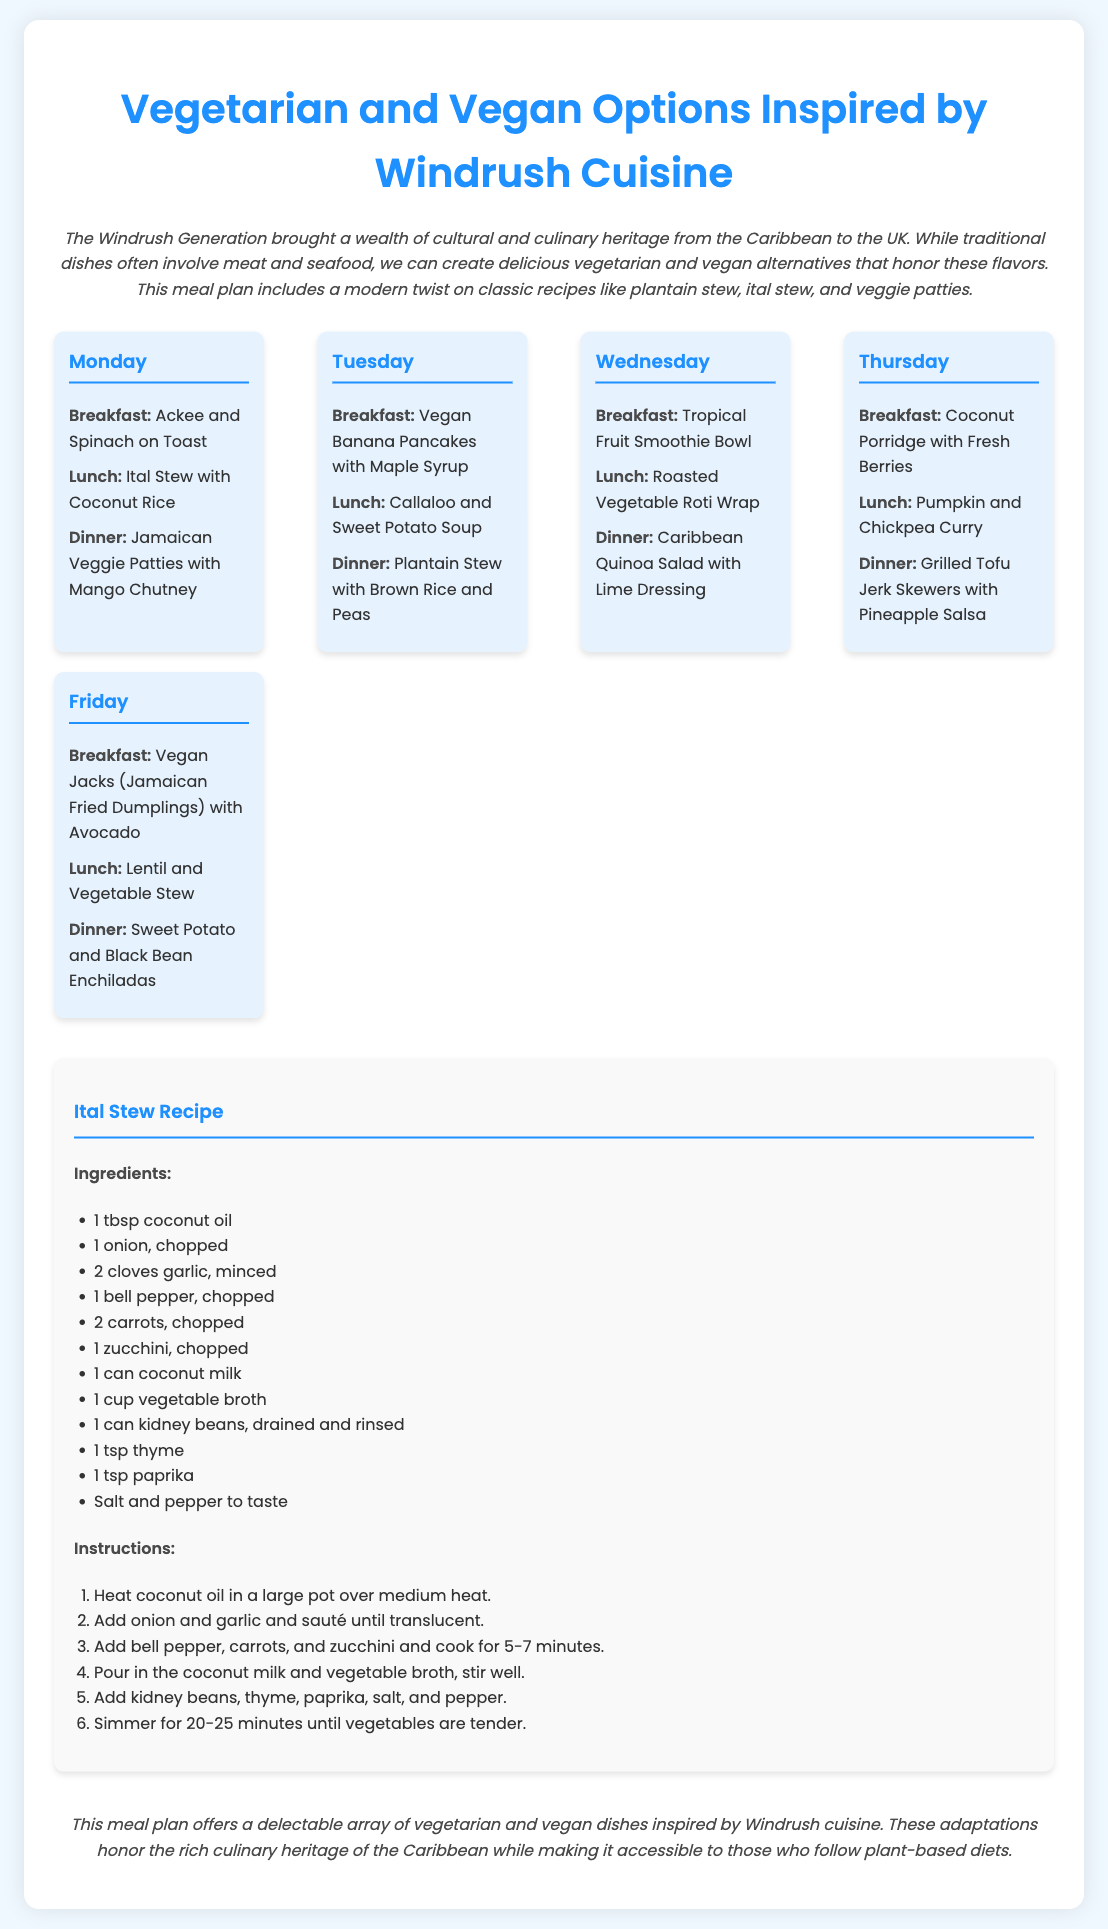What is the title of the document? The title of the document is specified in the <title> tag.
Answer: Vegetarian and Vegan Options Inspired by Windrush Cuisine How many days are included in the meal plan? The meal plan contains meals for five days, as indicated by the days listed.
Answer: Five What is the breakfast option for Tuesday? The breakfast option for Tuesday is listed in the corresponding section of the meal plan.
Answer: Vegan Banana Pancakes with Maple Syrup What main ingredient is used in the Ital Stew recipe? The main ingredients of the Ital Stew recipe are listed under the "Ingredients" section.
Answer: Coconut milk Which meal includes Jamaican Veggie Patties? The meal featuring Jamaican Veggie Patties is mentioned under the dinner section of one specific day.
Answer: Dinner on Monday How many ingredients are required for the Ital Stew recipe? The number of ingredients can be counted from the list provided in the recipe section.
Answer: Eleven What is the focus of the meal plan? The focus of the meal plan is described in the introductory paragraph.
Answer: Vegetarian and vegan alternatives Which day features a Tropical Fruit Smoothie Bowl for breakfast? The day that features this breakfast is listed explicitly in the meal plan.
Answer: Wednesday 